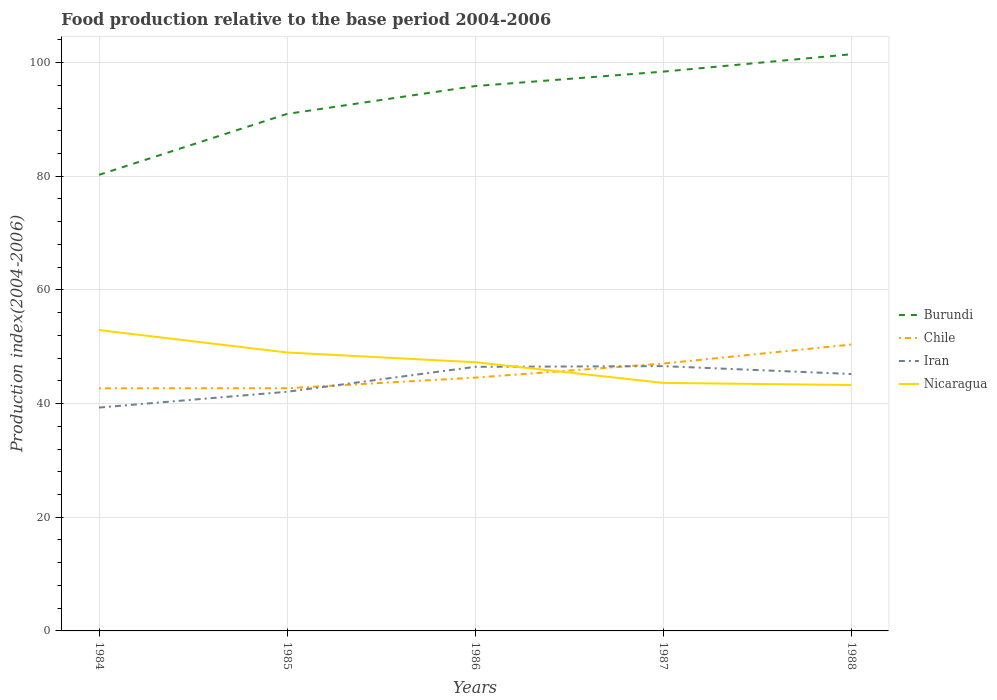Across all years, what is the maximum food production index in Iran?
Keep it short and to the point. 39.3. What is the total food production index in Iran in the graph?
Make the answer very short. -7.17. What is the difference between the highest and the second highest food production index in Iran?
Keep it short and to the point. 7.29. How many lines are there?
Provide a succinct answer. 4. How many years are there in the graph?
Offer a terse response. 5. Where does the legend appear in the graph?
Provide a short and direct response. Center right. What is the title of the graph?
Make the answer very short. Food production relative to the base period 2004-2006. Does "Korea (Republic)" appear as one of the legend labels in the graph?
Give a very brief answer. No. What is the label or title of the X-axis?
Your response must be concise. Years. What is the label or title of the Y-axis?
Make the answer very short. Production index(2004-2006). What is the Production index(2004-2006) in Burundi in 1984?
Your response must be concise. 80.25. What is the Production index(2004-2006) in Chile in 1984?
Your response must be concise. 42.69. What is the Production index(2004-2006) in Iran in 1984?
Provide a short and direct response. 39.3. What is the Production index(2004-2006) in Nicaragua in 1984?
Your response must be concise. 52.94. What is the Production index(2004-2006) of Burundi in 1985?
Your response must be concise. 90.97. What is the Production index(2004-2006) in Chile in 1985?
Offer a very short reply. 42.7. What is the Production index(2004-2006) in Iran in 1985?
Your answer should be compact. 42.08. What is the Production index(2004-2006) in Nicaragua in 1985?
Your response must be concise. 48.99. What is the Production index(2004-2006) in Burundi in 1986?
Offer a very short reply. 95.87. What is the Production index(2004-2006) in Chile in 1986?
Provide a short and direct response. 44.57. What is the Production index(2004-2006) of Iran in 1986?
Provide a succinct answer. 46.47. What is the Production index(2004-2006) of Nicaragua in 1986?
Your answer should be compact. 47.28. What is the Production index(2004-2006) of Burundi in 1987?
Provide a succinct answer. 98.41. What is the Production index(2004-2006) in Chile in 1987?
Your answer should be compact. 47.04. What is the Production index(2004-2006) of Iran in 1987?
Your answer should be compact. 46.59. What is the Production index(2004-2006) in Nicaragua in 1987?
Your answer should be compact. 43.64. What is the Production index(2004-2006) of Burundi in 1988?
Your answer should be compact. 101.47. What is the Production index(2004-2006) in Chile in 1988?
Provide a short and direct response. 50.39. What is the Production index(2004-2006) in Iran in 1988?
Offer a terse response. 45.21. What is the Production index(2004-2006) of Nicaragua in 1988?
Give a very brief answer. 43.27. Across all years, what is the maximum Production index(2004-2006) of Burundi?
Offer a very short reply. 101.47. Across all years, what is the maximum Production index(2004-2006) in Chile?
Your response must be concise. 50.39. Across all years, what is the maximum Production index(2004-2006) of Iran?
Your response must be concise. 46.59. Across all years, what is the maximum Production index(2004-2006) in Nicaragua?
Provide a short and direct response. 52.94. Across all years, what is the minimum Production index(2004-2006) in Burundi?
Keep it short and to the point. 80.25. Across all years, what is the minimum Production index(2004-2006) of Chile?
Ensure brevity in your answer.  42.69. Across all years, what is the minimum Production index(2004-2006) of Iran?
Make the answer very short. 39.3. Across all years, what is the minimum Production index(2004-2006) of Nicaragua?
Your response must be concise. 43.27. What is the total Production index(2004-2006) in Burundi in the graph?
Make the answer very short. 466.97. What is the total Production index(2004-2006) in Chile in the graph?
Keep it short and to the point. 227.39. What is the total Production index(2004-2006) in Iran in the graph?
Your response must be concise. 219.65. What is the total Production index(2004-2006) in Nicaragua in the graph?
Offer a terse response. 236.12. What is the difference between the Production index(2004-2006) in Burundi in 1984 and that in 1985?
Your answer should be very brief. -10.72. What is the difference between the Production index(2004-2006) of Chile in 1984 and that in 1985?
Provide a short and direct response. -0.01. What is the difference between the Production index(2004-2006) in Iran in 1984 and that in 1985?
Provide a succinct answer. -2.78. What is the difference between the Production index(2004-2006) in Nicaragua in 1984 and that in 1985?
Offer a very short reply. 3.95. What is the difference between the Production index(2004-2006) in Burundi in 1984 and that in 1986?
Ensure brevity in your answer.  -15.62. What is the difference between the Production index(2004-2006) of Chile in 1984 and that in 1986?
Your response must be concise. -1.88. What is the difference between the Production index(2004-2006) of Iran in 1984 and that in 1986?
Your answer should be compact. -7.17. What is the difference between the Production index(2004-2006) in Nicaragua in 1984 and that in 1986?
Your answer should be very brief. 5.66. What is the difference between the Production index(2004-2006) of Burundi in 1984 and that in 1987?
Your response must be concise. -18.16. What is the difference between the Production index(2004-2006) of Chile in 1984 and that in 1987?
Your response must be concise. -4.35. What is the difference between the Production index(2004-2006) of Iran in 1984 and that in 1987?
Your answer should be compact. -7.29. What is the difference between the Production index(2004-2006) of Nicaragua in 1984 and that in 1987?
Keep it short and to the point. 9.3. What is the difference between the Production index(2004-2006) in Burundi in 1984 and that in 1988?
Offer a terse response. -21.22. What is the difference between the Production index(2004-2006) of Chile in 1984 and that in 1988?
Keep it short and to the point. -7.7. What is the difference between the Production index(2004-2006) of Iran in 1984 and that in 1988?
Your answer should be very brief. -5.91. What is the difference between the Production index(2004-2006) of Nicaragua in 1984 and that in 1988?
Your answer should be compact. 9.67. What is the difference between the Production index(2004-2006) of Burundi in 1985 and that in 1986?
Provide a succinct answer. -4.9. What is the difference between the Production index(2004-2006) of Chile in 1985 and that in 1986?
Make the answer very short. -1.87. What is the difference between the Production index(2004-2006) of Iran in 1985 and that in 1986?
Offer a very short reply. -4.39. What is the difference between the Production index(2004-2006) in Nicaragua in 1985 and that in 1986?
Your answer should be compact. 1.71. What is the difference between the Production index(2004-2006) of Burundi in 1985 and that in 1987?
Provide a succinct answer. -7.44. What is the difference between the Production index(2004-2006) in Chile in 1985 and that in 1987?
Make the answer very short. -4.34. What is the difference between the Production index(2004-2006) of Iran in 1985 and that in 1987?
Give a very brief answer. -4.51. What is the difference between the Production index(2004-2006) of Nicaragua in 1985 and that in 1987?
Your answer should be very brief. 5.35. What is the difference between the Production index(2004-2006) in Burundi in 1985 and that in 1988?
Offer a very short reply. -10.5. What is the difference between the Production index(2004-2006) in Chile in 1985 and that in 1988?
Offer a very short reply. -7.69. What is the difference between the Production index(2004-2006) in Iran in 1985 and that in 1988?
Provide a short and direct response. -3.13. What is the difference between the Production index(2004-2006) of Nicaragua in 1985 and that in 1988?
Make the answer very short. 5.72. What is the difference between the Production index(2004-2006) of Burundi in 1986 and that in 1987?
Offer a very short reply. -2.54. What is the difference between the Production index(2004-2006) in Chile in 1986 and that in 1987?
Make the answer very short. -2.47. What is the difference between the Production index(2004-2006) of Iran in 1986 and that in 1987?
Offer a terse response. -0.12. What is the difference between the Production index(2004-2006) of Nicaragua in 1986 and that in 1987?
Give a very brief answer. 3.64. What is the difference between the Production index(2004-2006) in Chile in 1986 and that in 1988?
Keep it short and to the point. -5.82. What is the difference between the Production index(2004-2006) in Iran in 1986 and that in 1988?
Offer a very short reply. 1.26. What is the difference between the Production index(2004-2006) in Nicaragua in 1986 and that in 1988?
Ensure brevity in your answer.  4.01. What is the difference between the Production index(2004-2006) of Burundi in 1987 and that in 1988?
Your answer should be compact. -3.06. What is the difference between the Production index(2004-2006) in Chile in 1987 and that in 1988?
Ensure brevity in your answer.  -3.35. What is the difference between the Production index(2004-2006) in Iran in 1987 and that in 1988?
Your answer should be very brief. 1.38. What is the difference between the Production index(2004-2006) of Nicaragua in 1987 and that in 1988?
Your answer should be compact. 0.37. What is the difference between the Production index(2004-2006) in Burundi in 1984 and the Production index(2004-2006) in Chile in 1985?
Offer a very short reply. 37.55. What is the difference between the Production index(2004-2006) in Burundi in 1984 and the Production index(2004-2006) in Iran in 1985?
Offer a very short reply. 38.17. What is the difference between the Production index(2004-2006) in Burundi in 1984 and the Production index(2004-2006) in Nicaragua in 1985?
Offer a terse response. 31.26. What is the difference between the Production index(2004-2006) in Chile in 1984 and the Production index(2004-2006) in Iran in 1985?
Provide a succinct answer. 0.61. What is the difference between the Production index(2004-2006) of Iran in 1984 and the Production index(2004-2006) of Nicaragua in 1985?
Your answer should be compact. -9.69. What is the difference between the Production index(2004-2006) in Burundi in 1984 and the Production index(2004-2006) in Chile in 1986?
Give a very brief answer. 35.68. What is the difference between the Production index(2004-2006) in Burundi in 1984 and the Production index(2004-2006) in Iran in 1986?
Give a very brief answer. 33.78. What is the difference between the Production index(2004-2006) in Burundi in 1984 and the Production index(2004-2006) in Nicaragua in 1986?
Your response must be concise. 32.97. What is the difference between the Production index(2004-2006) of Chile in 1984 and the Production index(2004-2006) of Iran in 1986?
Ensure brevity in your answer.  -3.78. What is the difference between the Production index(2004-2006) in Chile in 1984 and the Production index(2004-2006) in Nicaragua in 1986?
Make the answer very short. -4.59. What is the difference between the Production index(2004-2006) in Iran in 1984 and the Production index(2004-2006) in Nicaragua in 1986?
Give a very brief answer. -7.98. What is the difference between the Production index(2004-2006) in Burundi in 1984 and the Production index(2004-2006) in Chile in 1987?
Provide a succinct answer. 33.21. What is the difference between the Production index(2004-2006) in Burundi in 1984 and the Production index(2004-2006) in Iran in 1987?
Keep it short and to the point. 33.66. What is the difference between the Production index(2004-2006) of Burundi in 1984 and the Production index(2004-2006) of Nicaragua in 1987?
Provide a short and direct response. 36.61. What is the difference between the Production index(2004-2006) in Chile in 1984 and the Production index(2004-2006) in Iran in 1987?
Your answer should be compact. -3.9. What is the difference between the Production index(2004-2006) in Chile in 1984 and the Production index(2004-2006) in Nicaragua in 1987?
Keep it short and to the point. -0.95. What is the difference between the Production index(2004-2006) in Iran in 1984 and the Production index(2004-2006) in Nicaragua in 1987?
Keep it short and to the point. -4.34. What is the difference between the Production index(2004-2006) of Burundi in 1984 and the Production index(2004-2006) of Chile in 1988?
Offer a very short reply. 29.86. What is the difference between the Production index(2004-2006) of Burundi in 1984 and the Production index(2004-2006) of Iran in 1988?
Provide a succinct answer. 35.04. What is the difference between the Production index(2004-2006) in Burundi in 1984 and the Production index(2004-2006) in Nicaragua in 1988?
Offer a terse response. 36.98. What is the difference between the Production index(2004-2006) in Chile in 1984 and the Production index(2004-2006) in Iran in 1988?
Provide a short and direct response. -2.52. What is the difference between the Production index(2004-2006) of Chile in 1984 and the Production index(2004-2006) of Nicaragua in 1988?
Your answer should be compact. -0.58. What is the difference between the Production index(2004-2006) of Iran in 1984 and the Production index(2004-2006) of Nicaragua in 1988?
Make the answer very short. -3.97. What is the difference between the Production index(2004-2006) of Burundi in 1985 and the Production index(2004-2006) of Chile in 1986?
Ensure brevity in your answer.  46.4. What is the difference between the Production index(2004-2006) in Burundi in 1985 and the Production index(2004-2006) in Iran in 1986?
Your response must be concise. 44.5. What is the difference between the Production index(2004-2006) of Burundi in 1985 and the Production index(2004-2006) of Nicaragua in 1986?
Make the answer very short. 43.69. What is the difference between the Production index(2004-2006) in Chile in 1985 and the Production index(2004-2006) in Iran in 1986?
Provide a succinct answer. -3.77. What is the difference between the Production index(2004-2006) in Chile in 1985 and the Production index(2004-2006) in Nicaragua in 1986?
Your answer should be compact. -4.58. What is the difference between the Production index(2004-2006) of Burundi in 1985 and the Production index(2004-2006) of Chile in 1987?
Provide a short and direct response. 43.93. What is the difference between the Production index(2004-2006) of Burundi in 1985 and the Production index(2004-2006) of Iran in 1987?
Offer a very short reply. 44.38. What is the difference between the Production index(2004-2006) in Burundi in 1985 and the Production index(2004-2006) in Nicaragua in 1987?
Your answer should be compact. 47.33. What is the difference between the Production index(2004-2006) in Chile in 1985 and the Production index(2004-2006) in Iran in 1987?
Your answer should be compact. -3.89. What is the difference between the Production index(2004-2006) of Chile in 1985 and the Production index(2004-2006) of Nicaragua in 1987?
Offer a very short reply. -0.94. What is the difference between the Production index(2004-2006) of Iran in 1985 and the Production index(2004-2006) of Nicaragua in 1987?
Offer a terse response. -1.56. What is the difference between the Production index(2004-2006) of Burundi in 1985 and the Production index(2004-2006) of Chile in 1988?
Provide a succinct answer. 40.58. What is the difference between the Production index(2004-2006) in Burundi in 1985 and the Production index(2004-2006) in Iran in 1988?
Offer a very short reply. 45.76. What is the difference between the Production index(2004-2006) in Burundi in 1985 and the Production index(2004-2006) in Nicaragua in 1988?
Your answer should be compact. 47.7. What is the difference between the Production index(2004-2006) in Chile in 1985 and the Production index(2004-2006) in Iran in 1988?
Your response must be concise. -2.51. What is the difference between the Production index(2004-2006) in Chile in 1985 and the Production index(2004-2006) in Nicaragua in 1988?
Your answer should be very brief. -0.57. What is the difference between the Production index(2004-2006) in Iran in 1985 and the Production index(2004-2006) in Nicaragua in 1988?
Keep it short and to the point. -1.19. What is the difference between the Production index(2004-2006) in Burundi in 1986 and the Production index(2004-2006) in Chile in 1987?
Your answer should be compact. 48.83. What is the difference between the Production index(2004-2006) of Burundi in 1986 and the Production index(2004-2006) of Iran in 1987?
Provide a succinct answer. 49.28. What is the difference between the Production index(2004-2006) in Burundi in 1986 and the Production index(2004-2006) in Nicaragua in 1987?
Give a very brief answer. 52.23. What is the difference between the Production index(2004-2006) in Chile in 1986 and the Production index(2004-2006) in Iran in 1987?
Make the answer very short. -2.02. What is the difference between the Production index(2004-2006) in Iran in 1986 and the Production index(2004-2006) in Nicaragua in 1987?
Your answer should be very brief. 2.83. What is the difference between the Production index(2004-2006) of Burundi in 1986 and the Production index(2004-2006) of Chile in 1988?
Provide a short and direct response. 45.48. What is the difference between the Production index(2004-2006) of Burundi in 1986 and the Production index(2004-2006) of Iran in 1988?
Your answer should be very brief. 50.66. What is the difference between the Production index(2004-2006) of Burundi in 1986 and the Production index(2004-2006) of Nicaragua in 1988?
Your answer should be compact. 52.6. What is the difference between the Production index(2004-2006) of Chile in 1986 and the Production index(2004-2006) of Iran in 1988?
Make the answer very short. -0.64. What is the difference between the Production index(2004-2006) of Iran in 1986 and the Production index(2004-2006) of Nicaragua in 1988?
Provide a short and direct response. 3.2. What is the difference between the Production index(2004-2006) in Burundi in 1987 and the Production index(2004-2006) in Chile in 1988?
Provide a short and direct response. 48.02. What is the difference between the Production index(2004-2006) in Burundi in 1987 and the Production index(2004-2006) in Iran in 1988?
Give a very brief answer. 53.2. What is the difference between the Production index(2004-2006) of Burundi in 1987 and the Production index(2004-2006) of Nicaragua in 1988?
Provide a short and direct response. 55.14. What is the difference between the Production index(2004-2006) in Chile in 1987 and the Production index(2004-2006) in Iran in 1988?
Your answer should be very brief. 1.83. What is the difference between the Production index(2004-2006) in Chile in 1987 and the Production index(2004-2006) in Nicaragua in 1988?
Keep it short and to the point. 3.77. What is the difference between the Production index(2004-2006) in Iran in 1987 and the Production index(2004-2006) in Nicaragua in 1988?
Offer a very short reply. 3.32. What is the average Production index(2004-2006) of Burundi per year?
Your response must be concise. 93.39. What is the average Production index(2004-2006) of Chile per year?
Ensure brevity in your answer.  45.48. What is the average Production index(2004-2006) of Iran per year?
Provide a succinct answer. 43.93. What is the average Production index(2004-2006) in Nicaragua per year?
Offer a terse response. 47.22. In the year 1984, what is the difference between the Production index(2004-2006) of Burundi and Production index(2004-2006) of Chile?
Provide a succinct answer. 37.56. In the year 1984, what is the difference between the Production index(2004-2006) in Burundi and Production index(2004-2006) in Iran?
Your response must be concise. 40.95. In the year 1984, what is the difference between the Production index(2004-2006) in Burundi and Production index(2004-2006) in Nicaragua?
Your response must be concise. 27.31. In the year 1984, what is the difference between the Production index(2004-2006) of Chile and Production index(2004-2006) of Iran?
Your response must be concise. 3.39. In the year 1984, what is the difference between the Production index(2004-2006) of Chile and Production index(2004-2006) of Nicaragua?
Give a very brief answer. -10.25. In the year 1984, what is the difference between the Production index(2004-2006) in Iran and Production index(2004-2006) in Nicaragua?
Keep it short and to the point. -13.64. In the year 1985, what is the difference between the Production index(2004-2006) of Burundi and Production index(2004-2006) of Chile?
Keep it short and to the point. 48.27. In the year 1985, what is the difference between the Production index(2004-2006) of Burundi and Production index(2004-2006) of Iran?
Ensure brevity in your answer.  48.89. In the year 1985, what is the difference between the Production index(2004-2006) of Burundi and Production index(2004-2006) of Nicaragua?
Your response must be concise. 41.98. In the year 1985, what is the difference between the Production index(2004-2006) of Chile and Production index(2004-2006) of Iran?
Your answer should be very brief. 0.62. In the year 1985, what is the difference between the Production index(2004-2006) in Chile and Production index(2004-2006) in Nicaragua?
Offer a very short reply. -6.29. In the year 1985, what is the difference between the Production index(2004-2006) in Iran and Production index(2004-2006) in Nicaragua?
Your answer should be compact. -6.91. In the year 1986, what is the difference between the Production index(2004-2006) of Burundi and Production index(2004-2006) of Chile?
Provide a succinct answer. 51.3. In the year 1986, what is the difference between the Production index(2004-2006) of Burundi and Production index(2004-2006) of Iran?
Provide a short and direct response. 49.4. In the year 1986, what is the difference between the Production index(2004-2006) in Burundi and Production index(2004-2006) in Nicaragua?
Make the answer very short. 48.59. In the year 1986, what is the difference between the Production index(2004-2006) in Chile and Production index(2004-2006) in Nicaragua?
Ensure brevity in your answer.  -2.71. In the year 1986, what is the difference between the Production index(2004-2006) in Iran and Production index(2004-2006) in Nicaragua?
Make the answer very short. -0.81. In the year 1987, what is the difference between the Production index(2004-2006) of Burundi and Production index(2004-2006) of Chile?
Your answer should be very brief. 51.37. In the year 1987, what is the difference between the Production index(2004-2006) in Burundi and Production index(2004-2006) in Iran?
Offer a very short reply. 51.82. In the year 1987, what is the difference between the Production index(2004-2006) in Burundi and Production index(2004-2006) in Nicaragua?
Offer a very short reply. 54.77. In the year 1987, what is the difference between the Production index(2004-2006) in Chile and Production index(2004-2006) in Iran?
Provide a short and direct response. 0.45. In the year 1987, what is the difference between the Production index(2004-2006) in Chile and Production index(2004-2006) in Nicaragua?
Your response must be concise. 3.4. In the year 1987, what is the difference between the Production index(2004-2006) of Iran and Production index(2004-2006) of Nicaragua?
Your response must be concise. 2.95. In the year 1988, what is the difference between the Production index(2004-2006) in Burundi and Production index(2004-2006) in Chile?
Your answer should be compact. 51.08. In the year 1988, what is the difference between the Production index(2004-2006) of Burundi and Production index(2004-2006) of Iran?
Ensure brevity in your answer.  56.26. In the year 1988, what is the difference between the Production index(2004-2006) of Burundi and Production index(2004-2006) of Nicaragua?
Ensure brevity in your answer.  58.2. In the year 1988, what is the difference between the Production index(2004-2006) of Chile and Production index(2004-2006) of Iran?
Give a very brief answer. 5.18. In the year 1988, what is the difference between the Production index(2004-2006) in Chile and Production index(2004-2006) in Nicaragua?
Provide a succinct answer. 7.12. In the year 1988, what is the difference between the Production index(2004-2006) in Iran and Production index(2004-2006) in Nicaragua?
Provide a succinct answer. 1.94. What is the ratio of the Production index(2004-2006) in Burundi in 1984 to that in 1985?
Your answer should be very brief. 0.88. What is the ratio of the Production index(2004-2006) in Iran in 1984 to that in 1985?
Offer a terse response. 0.93. What is the ratio of the Production index(2004-2006) of Nicaragua in 1984 to that in 1985?
Your answer should be very brief. 1.08. What is the ratio of the Production index(2004-2006) in Burundi in 1984 to that in 1986?
Your response must be concise. 0.84. What is the ratio of the Production index(2004-2006) of Chile in 1984 to that in 1986?
Offer a very short reply. 0.96. What is the ratio of the Production index(2004-2006) in Iran in 1984 to that in 1986?
Keep it short and to the point. 0.85. What is the ratio of the Production index(2004-2006) of Nicaragua in 1984 to that in 1986?
Ensure brevity in your answer.  1.12. What is the ratio of the Production index(2004-2006) of Burundi in 1984 to that in 1987?
Provide a succinct answer. 0.82. What is the ratio of the Production index(2004-2006) of Chile in 1984 to that in 1987?
Ensure brevity in your answer.  0.91. What is the ratio of the Production index(2004-2006) in Iran in 1984 to that in 1987?
Your response must be concise. 0.84. What is the ratio of the Production index(2004-2006) in Nicaragua in 1984 to that in 1987?
Ensure brevity in your answer.  1.21. What is the ratio of the Production index(2004-2006) of Burundi in 1984 to that in 1988?
Make the answer very short. 0.79. What is the ratio of the Production index(2004-2006) of Chile in 1984 to that in 1988?
Keep it short and to the point. 0.85. What is the ratio of the Production index(2004-2006) in Iran in 1984 to that in 1988?
Offer a terse response. 0.87. What is the ratio of the Production index(2004-2006) in Nicaragua in 1984 to that in 1988?
Provide a short and direct response. 1.22. What is the ratio of the Production index(2004-2006) in Burundi in 1985 to that in 1986?
Offer a very short reply. 0.95. What is the ratio of the Production index(2004-2006) in Chile in 1985 to that in 1986?
Provide a short and direct response. 0.96. What is the ratio of the Production index(2004-2006) of Iran in 1985 to that in 1986?
Make the answer very short. 0.91. What is the ratio of the Production index(2004-2006) in Nicaragua in 1985 to that in 1986?
Your response must be concise. 1.04. What is the ratio of the Production index(2004-2006) in Burundi in 1985 to that in 1987?
Offer a terse response. 0.92. What is the ratio of the Production index(2004-2006) in Chile in 1985 to that in 1987?
Your response must be concise. 0.91. What is the ratio of the Production index(2004-2006) in Iran in 1985 to that in 1987?
Your answer should be very brief. 0.9. What is the ratio of the Production index(2004-2006) of Nicaragua in 1985 to that in 1987?
Ensure brevity in your answer.  1.12. What is the ratio of the Production index(2004-2006) in Burundi in 1985 to that in 1988?
Give a very brief answer. 0.9. What is the ratio of the Production index(2004-2006) in Chile in 1985 to that in 1988?
Give a very brief answer. 0.85. What is the ratio of the Production index(2004-2006) in Iran in 1985 to that in 1988?
Offer a terse response. 0.93. What is the ratio of the Production index(2004-2006) in Nicaragua in 1985 to that in 1988?
Your response must be concise. 1.13. What is the ratio of the Production index(2004-2006) in Burundi in 1986 to that in 1987?
Provide a succinct answer. 0.97. What is the ratio of the Production index(2004-2006) in Chile in 1986 to that in 1987?
Your response must be concise. 0.95. What is the ratio of the Production index(2004-2006) of Nicaragua in 1986 to that in 1987?
Make the answer very short. 1.08. What is the ratio of the Production index(2004-2006) in Burundi in 1986 to that in 1988?
Your answer should be compact. 0.94. What is the ratio of the Production index(2004-2006) of Chile in 1986 to that in 1988?
Provide a short and direct response. 0.88. What is the ratio of the Production index(2004-2006) in Iran in 1986 to that in 1988?
Provide a succinct answer. 1.03. What is the ratio of the Production index(2004-2006) of Nicaragua in 1986 to that in 1988?
Offer a terse response. 1.09. What is the ratio of the Production index(2004-2006) of Burundi in 1987 to that in 1988?
Provide a short and direct response. 0.97. What is the ratio of the Production index(2004-2006) in Chile in 1987 to that in 1988?
Your response must be concise. 0.93. What is the ratio of the Production index(2004-2006) in Iran in 1987 to that in 1988?
Your answer should be compact. 1.03. What is the ratio of the Production index(2004-2006) in Nicaragua in 1987 to that in 1988?
Provide a succinct answer. 1.01. What is the difference between the highest and the second highest Production index(2004-2006) of Burundi?
Offer a terse response. 3.06. What is the difference between the highest and the second highest Production index(2004-2006) in Chile?
Your answer should be compact. 3.35. What is the difference between the highest and the second highest Production index(2004-2006) in Iran?
Offer a very short reply. 0.12. What is the difference between the highest and the second highest Production index(2004-2006) in Nicaragua?
Ensure brevity in your answer.  3.95. What is the difference between the highest and the lowest Production index(2004-2006) of Burundi?
Make the answer very short. 21.22. What is the difference between the highest and the lowest Production index(2004-2006) of Iran?
Provide a short and direct response. 7.29. What is the difference between the highest and the lowest Production index(2004-2006) of Nicaragua?
Give a very brief answer. 9.67. 